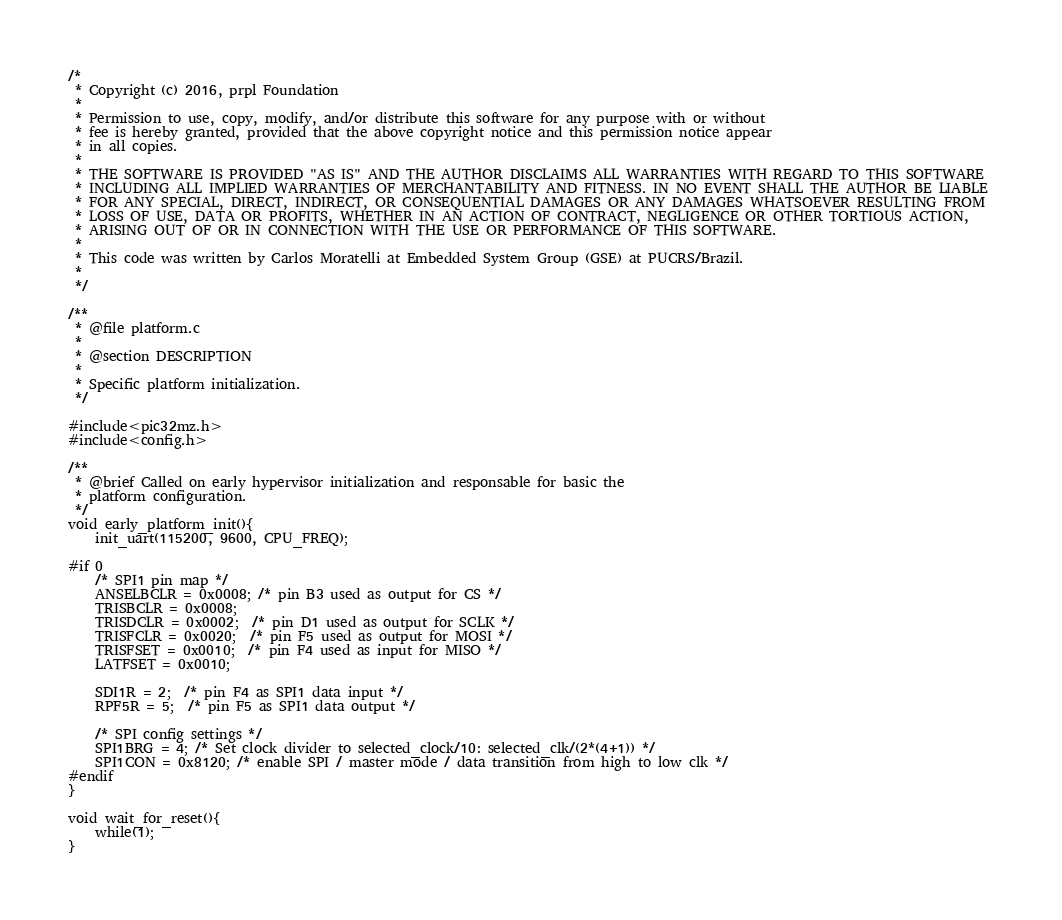<code> <loc_0><loc_0><loc_500><loc_500><_C_>/*
 * Copyright (c) 2016, prpl Foundation
 * 
 * Permission to use, copy, modify, and/or distribute this software for any purpose with or without 
 * fee is hereby granted, provided that the above copyright notice and this permission notice appear 
 * in all copies.
 * 
 * THE SOFTWARE IS PROVIDED "AS IS" AND THE AUTHOR DISCLAIMS ALL WARRANTIES WITH REGARD TO THIS SOFTWARE
 * INCLUDING ALL IMPLIED WARRANTIES OF MERCHANTABILITY AND FITNESS. IN NO EVENT SHALL THE AUTHOR BE LIABLE 
 * FOR ANY SPECIAL, DIRECT, INDIRECT, OR CONSEQUENTIAL DAMAGES OR ANY DAMAGES WHATSOEVER RESULTING FROM 
 * LOSS OF USE, DATA OR PROFITS, WHETHER IN AN ACTION OF CONTRACT, NEGLIGENCE OR OTHER TORTIOUS ACTION, 
 * ARISING OUT OF OR IN CONNECTION WITH THE USE OR PERFORMANCE OF THIS SOFTWARE.
 * 
 * This code was written by Carlos Moratelli at Embedded System Group (GSE) at PUCRS/Brazil.
 * 
 */

/**
 * @file platform.c
 * 
 * @section DESCRIPTION
 * 
 * Specific platform initialization.
 */

#include<pic32mz.h>
#include<config.h>

/**
 * @brief Called on early hypervisor initialization and responsable for basic the
 * platform configuration. 
 */
void early_platform_init(){
    init_uart(115200, 9600, CPU_FREQ);

#if 0    
    /* SPI1 pin map */
    ANSELBCLR = 0x0008; /* pin B3 used as output for CS */
    TRISBCLR = 0x0008;
    TRISDCLR = 0x0002;  /* pin D1 used as output for SCLK */
    TRISFCLR = 0x0020;  /* pin F5 used as output for MOSI */
    TRISFSET = 0x0010;  /* pin F4 used as input for MISO */
    LATFSET = 0x0010;

    SDI1R = 2;  /* pin F4 as SPI1 data input */
    RPF5R = 5;  /* pin F5 as SPI1 data output */

    /* SPI config settings */
    SPI1BRG = 4; /* Set clock divider to selected_clock/10: selected_clk/(2*(4+1)) */
    SPI1CON = 0x8120; /* enable SPI / master mode / data transition from high to low clk */
#endif     
}

void wait_for_reset(){
	while(1);
}
</code> 